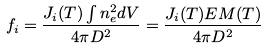<formula> <loc_0><loc_0><loc_500><loc_500>f _ { i } = \frac { J _ { i } ( T ) \int n _ { e } ^ { 2 } d V } { 4 \pi D ^ { 2 } } = \frac { J _ { i } ( T ) E M ( T ) } { 4 \pi D ^ { 2 } }</formula> 